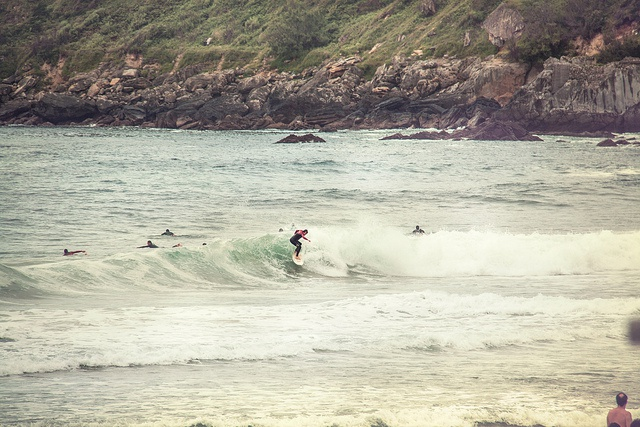Describe the objects in this image and their specific colors. I can see people in gray, purple, and salmon tones, people in gray, black, lightpink, and brown tones, people in gray, darkgray, brown, and lightgray tones, surfboard in gray, beige, tan, and darkgray tones, and people in gray, darkgray, and beige tones in this image. 